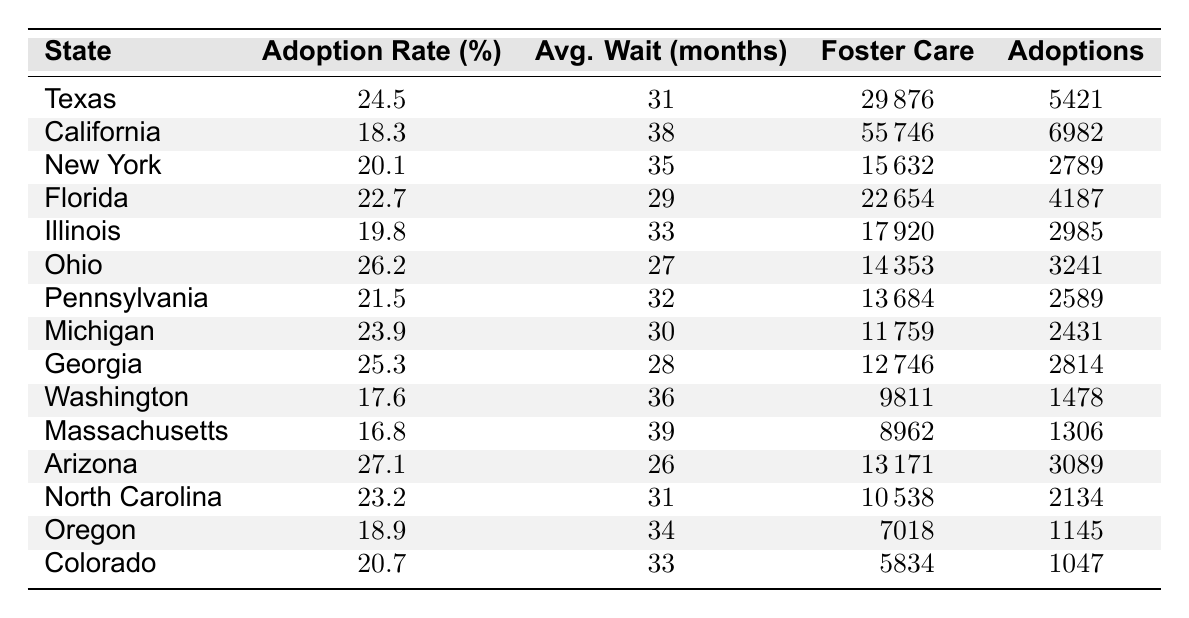What is the adoption rate in Texas? The table lists Texas with an adoption rate of 24.5%.
Answer: 24.5% Which state has the highest average wait time for adoption? California has the highest average wait time listed at 38 months according to the table.
Answer: California What is the total number of children in foster care across the states in the table? To find the total, sum the values of "Children in Foster Care" for each state: 29876 + 55746 + 15632 + 22654 + 17920 + 14353 + 13684 + 11759 + 12746 + 9811 + 8962 + 13171 + 10538 + 7018 + 5834 = 188,606.
Answer: 188606 Is the adoption rate in Georgia higher than the average wait time for adoption in Michigan? Georgia has an adoption rate of 25.3% and Michigan has an average wait time of 30 months; since 25.3% is not compared to months, we need to state that one is a percentage and the other is a time measure.
Answer: No, the comparison is invalid Which state has the lowest adoption rate, and what is that rate? Upon reviewing the table, Massachusetts shows the lowest adoption rate at 16.8%.
Answer: 16.8% How many successful adoptions were recorded in Ohio? The table indicates that Ohio had 3241 successful adoptions.
Answer: 3241 What is the difference in adoption rates between Arizona and Florida? Arizona has a rate of 27.1% and Florida has 22.7%. The difference is calculated as 27.1% - 22.7% = 4.4%.
Answer: 4.4% Which state has the most children in foster care, and how many are there? California has the most children in foster care at 55,746 according to the table.
Answer: California, 55746 Are there more successful adoptions in North Carolina than in Michigan? North Carolina has 2134 successful adoptions, while Michigan has 2431. Thus, Michigan has more successful adoptions.
Answer: No What is the average adoption rate among the states listed in the table? To calculate: sum the adoption rates and divide by the number of states (24.5 + 18.3 + 20.1 + 22.7 + 19.8 + 26.2 + 21.5 + 23.9 + 25.3 + 17.6 + 16.8 + 27.1 + 23.2 + 18.9 + 20.7) / 15 = 21.3%.
Answer: 21.3% 